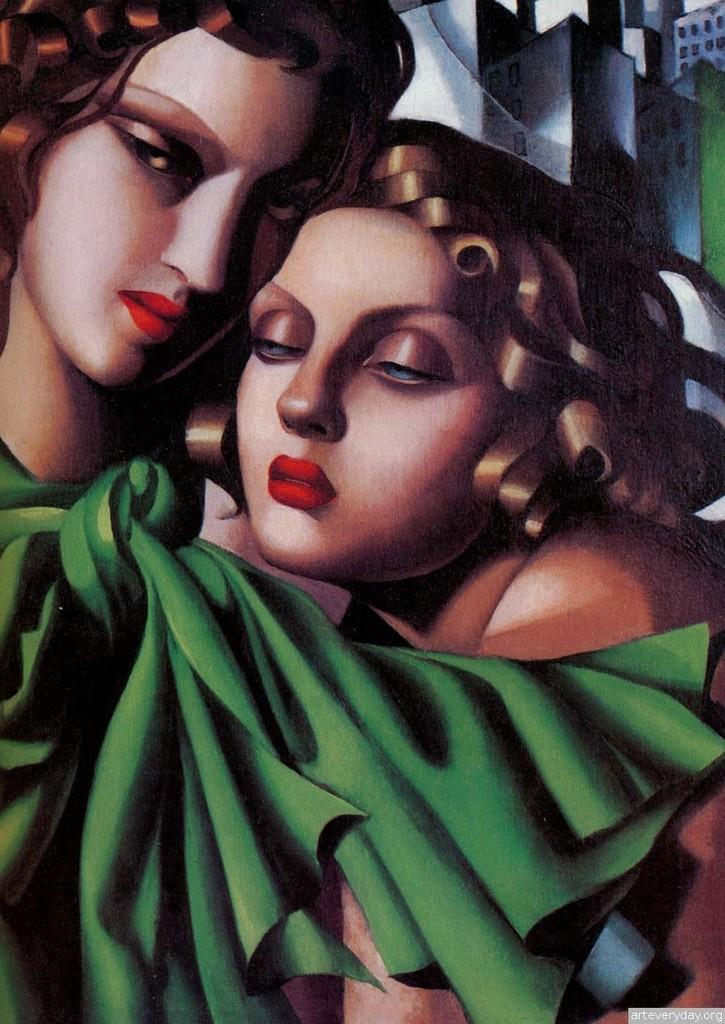What type of artwork is depicted in the image? The image is a painting. How many people are in the painting? There are two ladies in the painting. What are the ladies doing in the painting? The ladies are holding each other. What can be seen on one of the ladies in the painting? One of the ladies is wearing a green scarf. What type of cake is being served in the painting? There is no cake present in the painting; it features two ladies holding each other. What drug is being used by the ladies in the painting? There is no drug use depicted in the painting; it shows two ladies holding each other. 